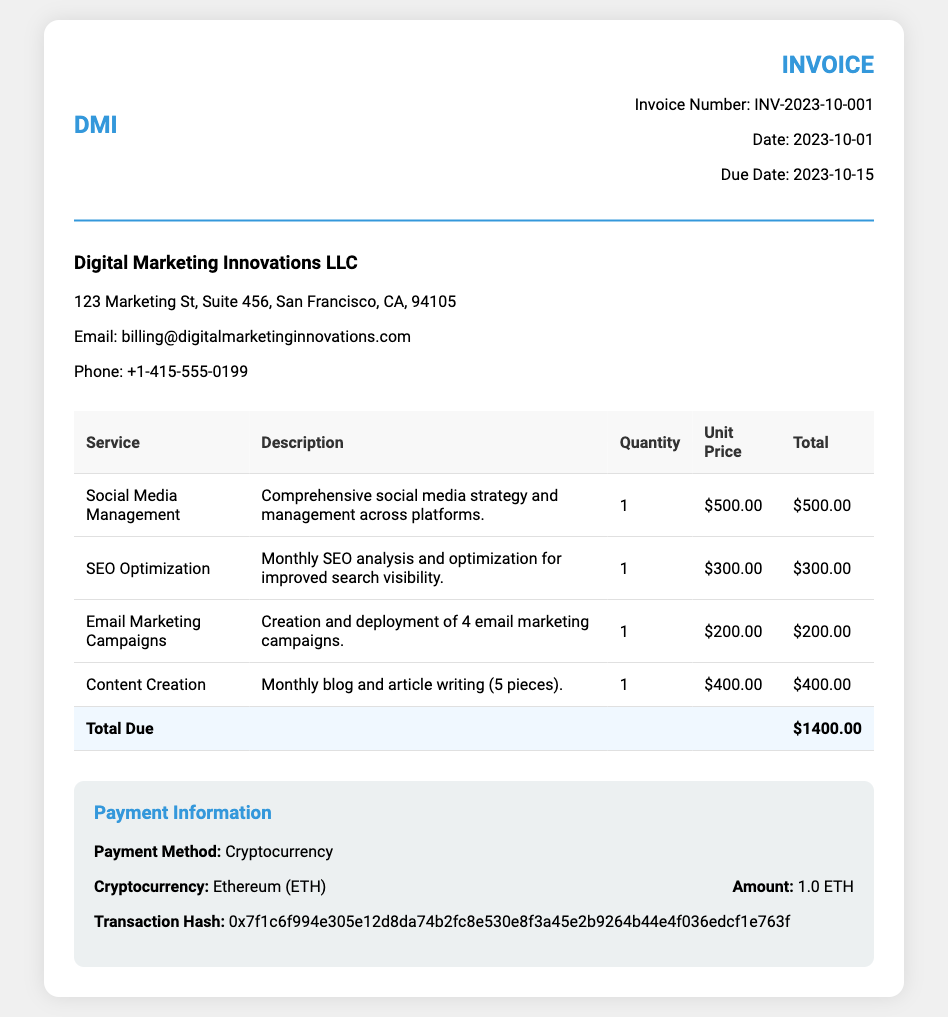What is the invoice number? The invoice number is explicitly stated in the document header.
Answer: INV-2023-10-001 What is the total amount due? The total amount due is calculated as the sum of all services listed in the invoice.
Answer: $1400.00 What services are provided in this invoice? The services listed detail the offerings provided for the subscription period.
Answer: Social Media Management, SEO Optimization, Email Marketing Campaigns, Content Creation What is the payment method? The document clearly mentions how the payment is being made.
Answer: Cryptocurrency What cryptocurrency was used for payment? The document specifies which cryptocurrency is being utilized for the payment.
Answer: Ethereum (ETH) What is the due date for the invoice? The due date for payment is provided within the invoice details.
Answer: 2023-10-15 What is the quantity of the "Email Marketing Campaigns" service? This detail is noted within the service breakdown table for clarity.
Answer: 1 What does the transaction hash indicate? The transaction hash is a unique identifier for the cryptocurrency transaction in the document.
Answer: 0x7f1c6f994e305e12d8da74b2fc8e530e8f3a45e2b9264b44e4f036edcf1e763f What is the date when the invoice was issued? The issuance date is listed prominently in the invoice header section.
Answer: 2023-10-01 